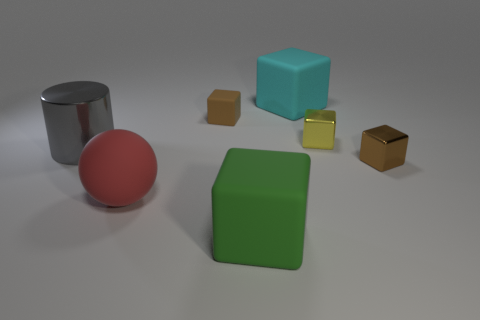Are there any other things that have the same color as the rubber ball?
Your answer should be very brief. No. What color is the metallic object on the left side of the large matte object behind the tiny cube that is to the left of the green cube?
Provide a short and direct response. Gray. Do the red matte thing and the shiny cylinder have the same size?
Your response must be concise. Yes. How many green rubber blocks have the same size as the gray metallic cylinder?
Your answer should be very brief. 1. There is a shiny object that is the same color as the tiny rubber object; what shape is it?
Your answer should be compact. Cube. Do the object to the left of the large red sphere and the big thing that is in front of the red ball have the same material?
Keep it short and to the point. No. Is there any other thing that is the same shape as the green matte thing?
Your answer should be very brief. Yes. What is the color of the large sphere?
Make the answer very short. Red. How many brown things are the same shape as the large cyan thing?
Offer a very short reply. 2. There is a metallic cylinder that is the same size as the green rubber cube; what color is it?
Provide a short and direct response. Gray. 